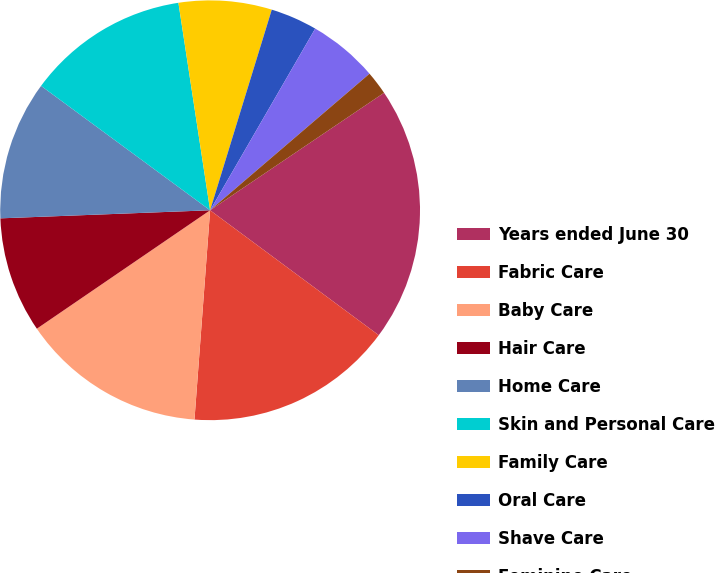Convert chart. <chart><loc_0><loc_0><loc_500><loc_500><pie_chart><fcel>Years ended June 30<fcel>Fabric Care<fcel>Baby Care<fcel>Hair Care<fcel>Home Care<fcel>Skin and Personal Care<fcel>Family Care<fcel>Oral Care<fcel>Shave Care<fcel>Feminine Care<nl><fcel>19.6%<fcel>16.04%<fcel>14.27%<fcel>8.93%<fcel>10.71%<fcel>12.49%<fcel>7.16%<fcel>3.6%<fcel>5.38%<fcel>1.82%<nl></chart> 